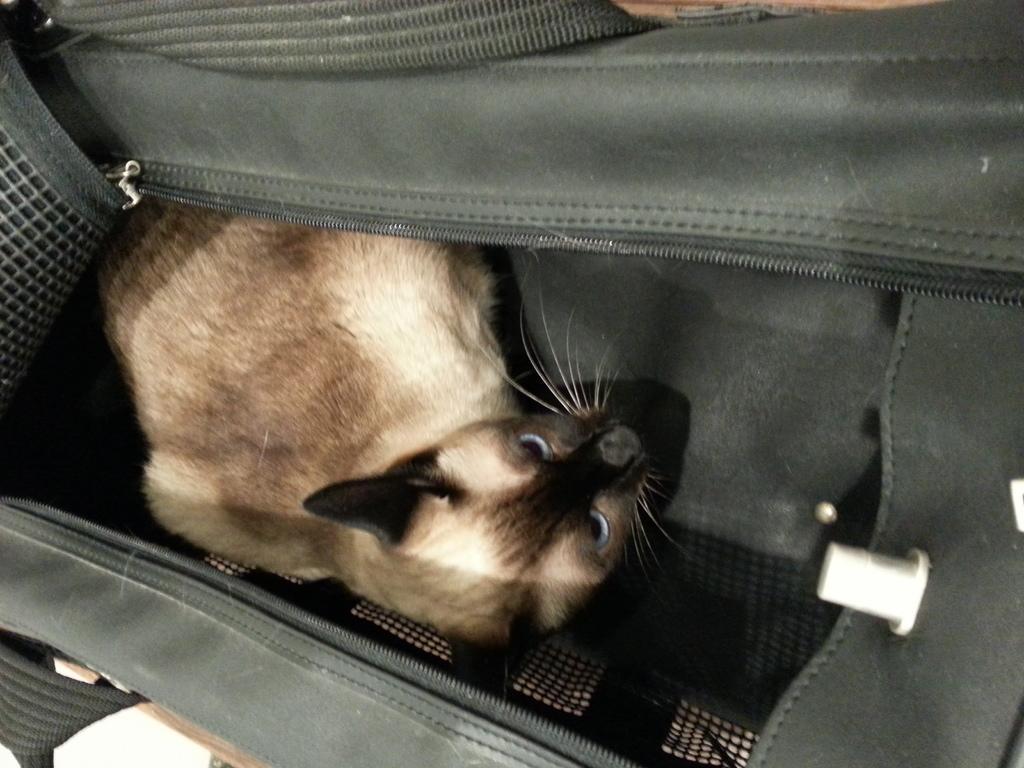How would you summarize this image in a sentence or two? This image consists of a bag. It is in black color. There is a cat sitting in that bag. 